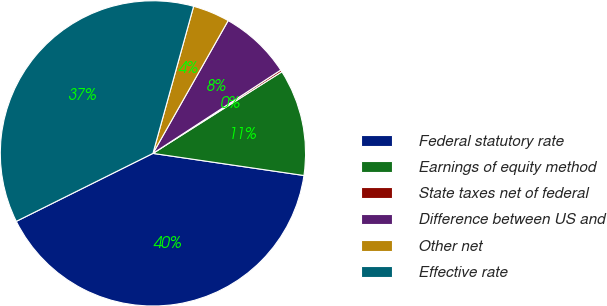<chart> <loc_0><loc_0><loc_500><loc_500><pie_chart><fcel>Federal statutory rate<fcel>Earnings of equity method<fcel>State taxes net of federal<fcel>Difference between US and<fcel>Other net<fcel>Effective rate<nl><fcel>40.34%<fcel>11.3%<fcel>0.21%<fcel>7.6%<fcel>3.91%<fcel>36.64%<nl></chart> 